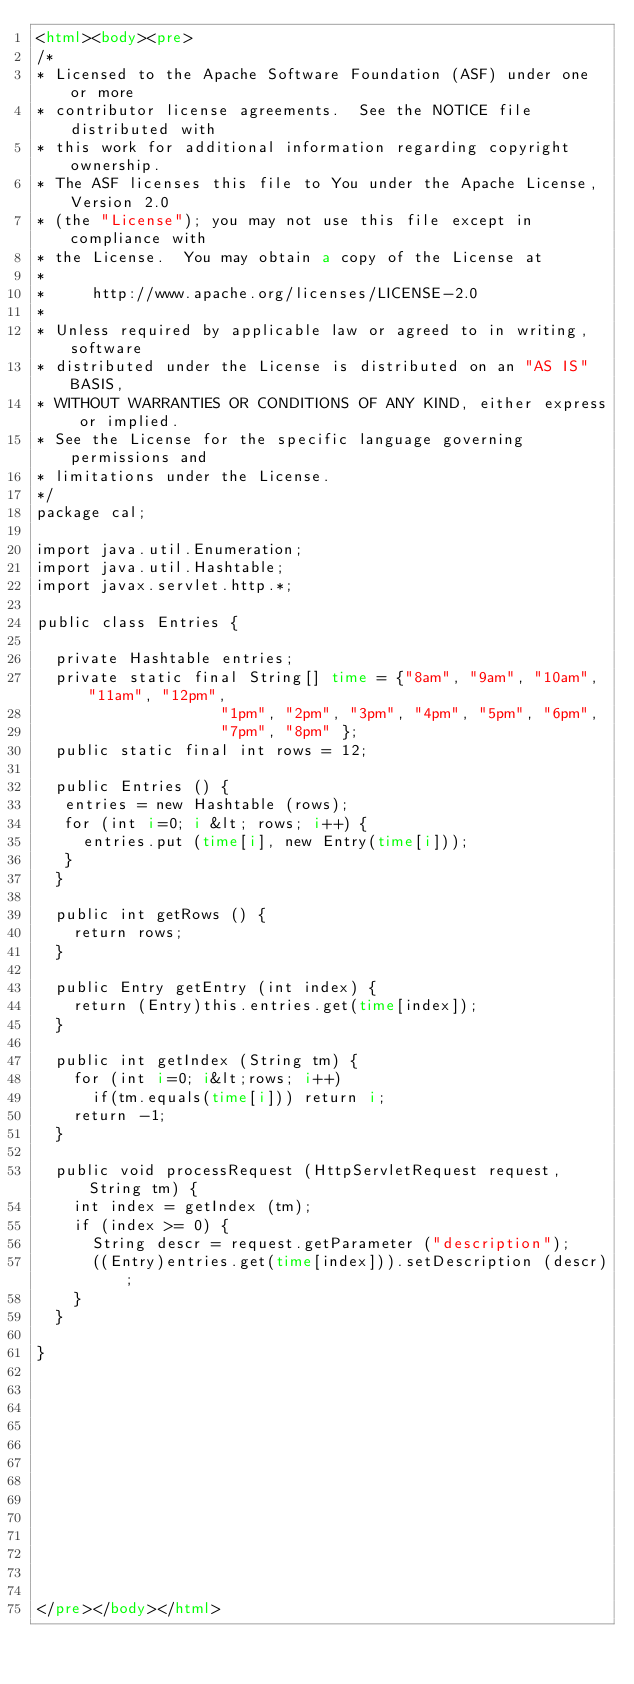Convert code to text. <code><loc_0><loc_0><loc_500><loc_500><_HTML_><html><body><pre>
/*
* Licensed to the Apache Software Foundation (ASF) under one or more
* contributor license agreements.  See the NOTICE file distributed with
* this work for additional information regarding copyright ownership.
* The ASF licenses this file to You under the Apache License, Version 2.0
* (the "License"); you may not use this file except in compliance with
* the License.  You may obtain a copy of the License at
*
*     http://www.apache.org/licenses/LICENSE-2.0
*
* Unless required by applicable law or agreed to in writing, software
* distributed under the License is distributed on an "AS IS" BASIS,
* WITHOUT WARRANTIES OR CONDITIONS OF ANY KIND, either express or implied.
* See the License for the specific language governing permissions and
* limitations under the License.
*/
package cal;

import java.util.Enumeration;
import java.util.Hashtable;
import javax.servlet.http.*;

public class Entries {

  private Hashtable entries;
  private static final String[] time = {"8am", "9am", "10am", "11am", "12pm", 
					"1pm", "2pm", "3pm", "4pm", "5pm", "6pm",
					"7pm", "8pm" };
  public static final int rows = 12;

  public Entries () {   
   entries = new Hashtable (rows);
   for (int i=0; i &lt; rows; i++) {
     entries.put (time[i], new Entry(time[i]));
   }
  }

  public int getRows () {
    return rows;
  }

  public Entry getEntry (int index) {
    return (Entry)this.entries.get(time[index]);
  }

  public int getIndex (String tm) {
    for (int i=0; i&lt;rows; i++)
      if(tm.equals(time[i])) return i;
    return -1;
  }

  public void processRequest (HttpServletRequest request, String tm) {
    int index = getIndex (tm);
    if (index >= 0) {
      String descr = request.getParameter ("description");
      ((Entry)entries.get(time[index])).setDescription (descr);
    }
  }

}













</pre></body></html>
</code> 